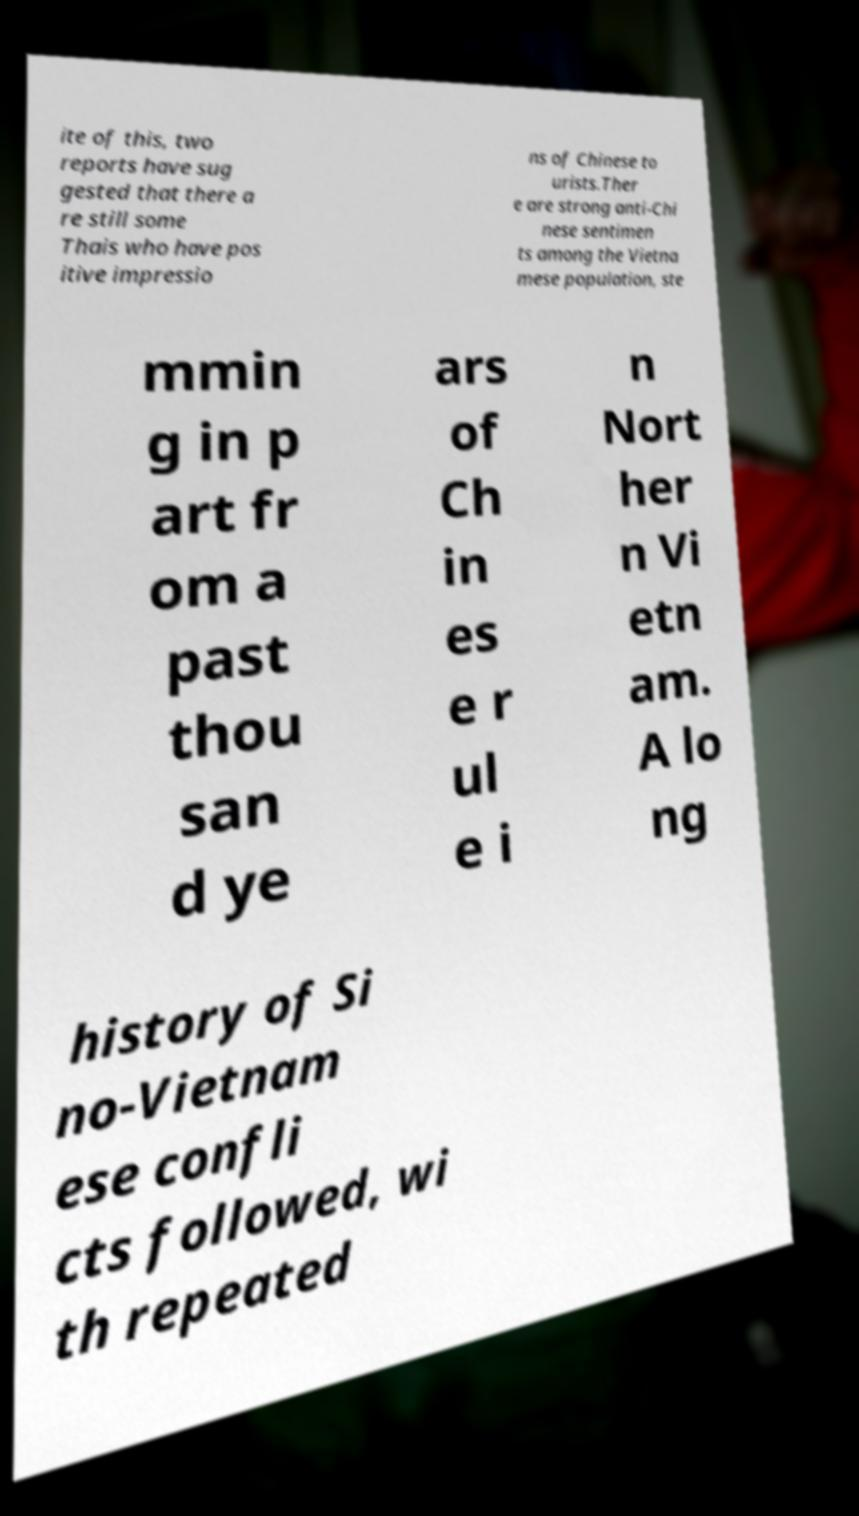Please read and relay the text visible in this image. What does it say? ite of this, two reports have sug gested that there a re still some Thais who have pos itive impressio ns of Chinese to urists.Ther e are strong anti-Chi nese sentimen ts among the Vietna mese population, ste mmin g in p art fr om a past thou san d ye ars of Ch in es e r ul e i n Nort her n Vi etn am. A lo ng history of Si no-Vietnam ese confli cts followed, wi th repeated 